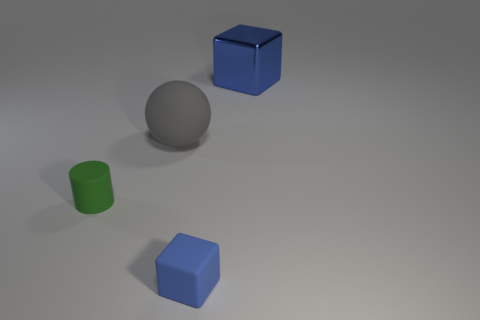Are there other objects in the image besides the ball? Yes, besides the silver ball, there are three other geometric shapes: a green cylinder, a blue cube, and a smaller light blue cube, all placed on a light grey surface. 